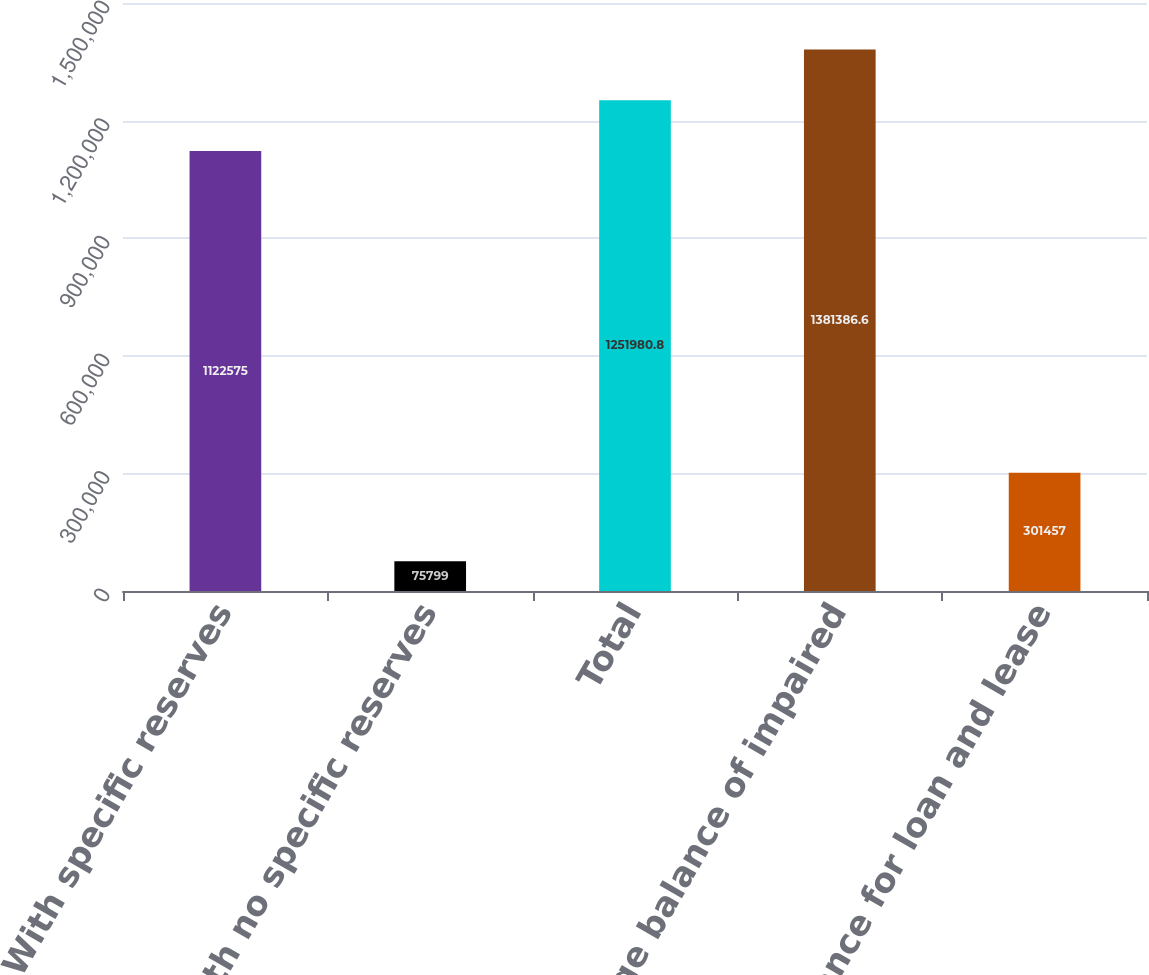<chart> <loc_0><loc_0><loc_500><loc_500><bar_chart><fcel>With specific reserves<fcel>With no specific reserves<fcel>Total<fcel>Average balance of impaired<fcel>Allowance for loan and lease<nl><fcel>1.12258e+06<fcel>75799<fcel>1.25198e+06<fcel>1.38139e+06<fcel>301457<nl></chart> 